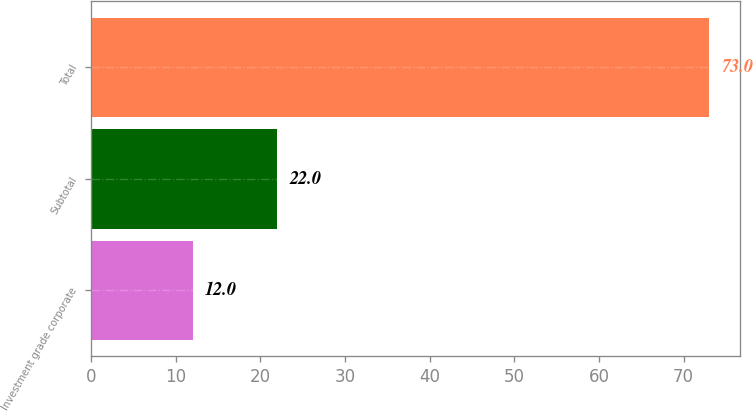Convert chart to OTSL. <chart><loc_0><loc_0><loc_500><loc_500><bar_chart><fcel>Investment grade corporate<fcel>Subtotal<fcel>Total<nl><fcel>12<fcel>22<fcel>73<nl></chart> 